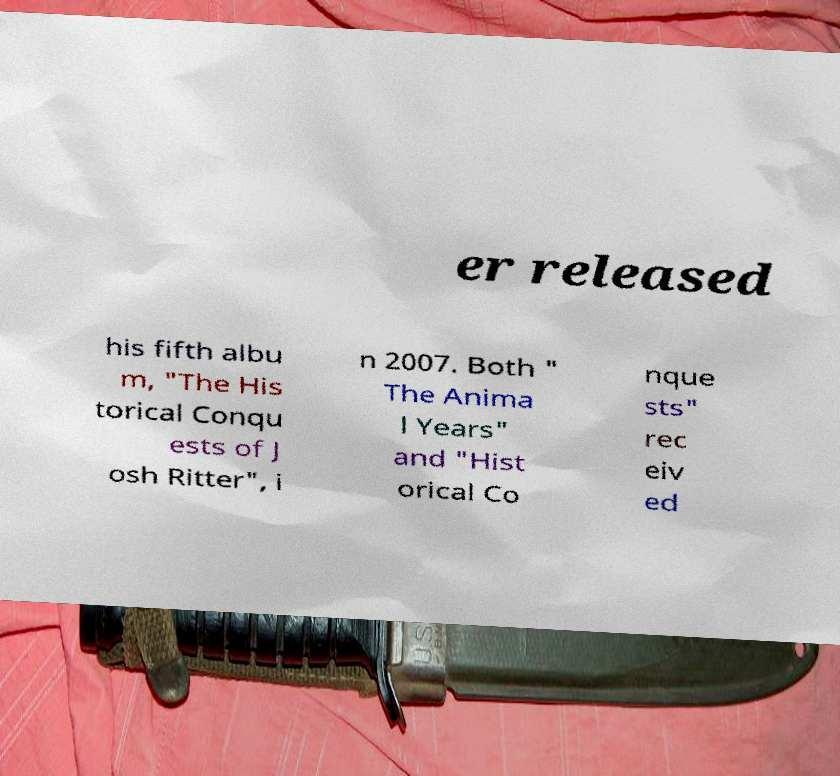I need the written content from this picture converted into text. Can you do that? er released his fifth albu m, "The His torical Conqu ests of J osh Ritter", i n 2007. Both " The Anima l Years" and "Hist orical Co nque sts" rec eiv ed 